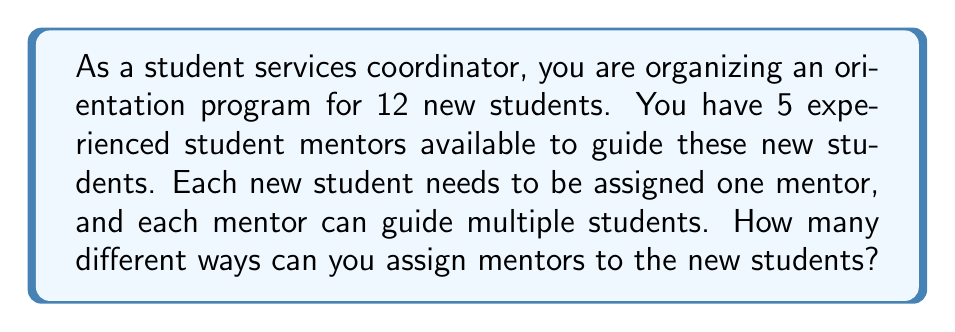Give your solution to this math problem. To solve this problem, we need to use the concept of permutations with repetition. Here's a step-by-step explanation:

1. We have 12 new students who each need to be assigned a mentor.
2. There are 5 mentors to choose from for each student.
3. The order of assignment matters (e.g., assigning Mentor A to Student 1 and Mentor B to Student 2 is different from assigning Mentor B to Student 1 and Mentor A to Student 2).
4. Each mentor can be assigned to multiple students (repetition is allowed).

This scenario fits the formula for permutations with repetition:

$$ n^r $$

Where:
- $n$ is the number of options for each choice (in this case, 5 mentors)
- $r$ is the number of choices to be made (in this case, 12 students)

Therefore, we can calculate the number of ways to assign mentors as follows:

$$ 5^{12} $$

Using a calculator or computer, we can evaluate this expression:

$$ 5^{12} = 244,140,625 $$

This means there are 244,140,625 different ways to assign the 5 mentors to the 12 new students.
Answer: 244,140,625 